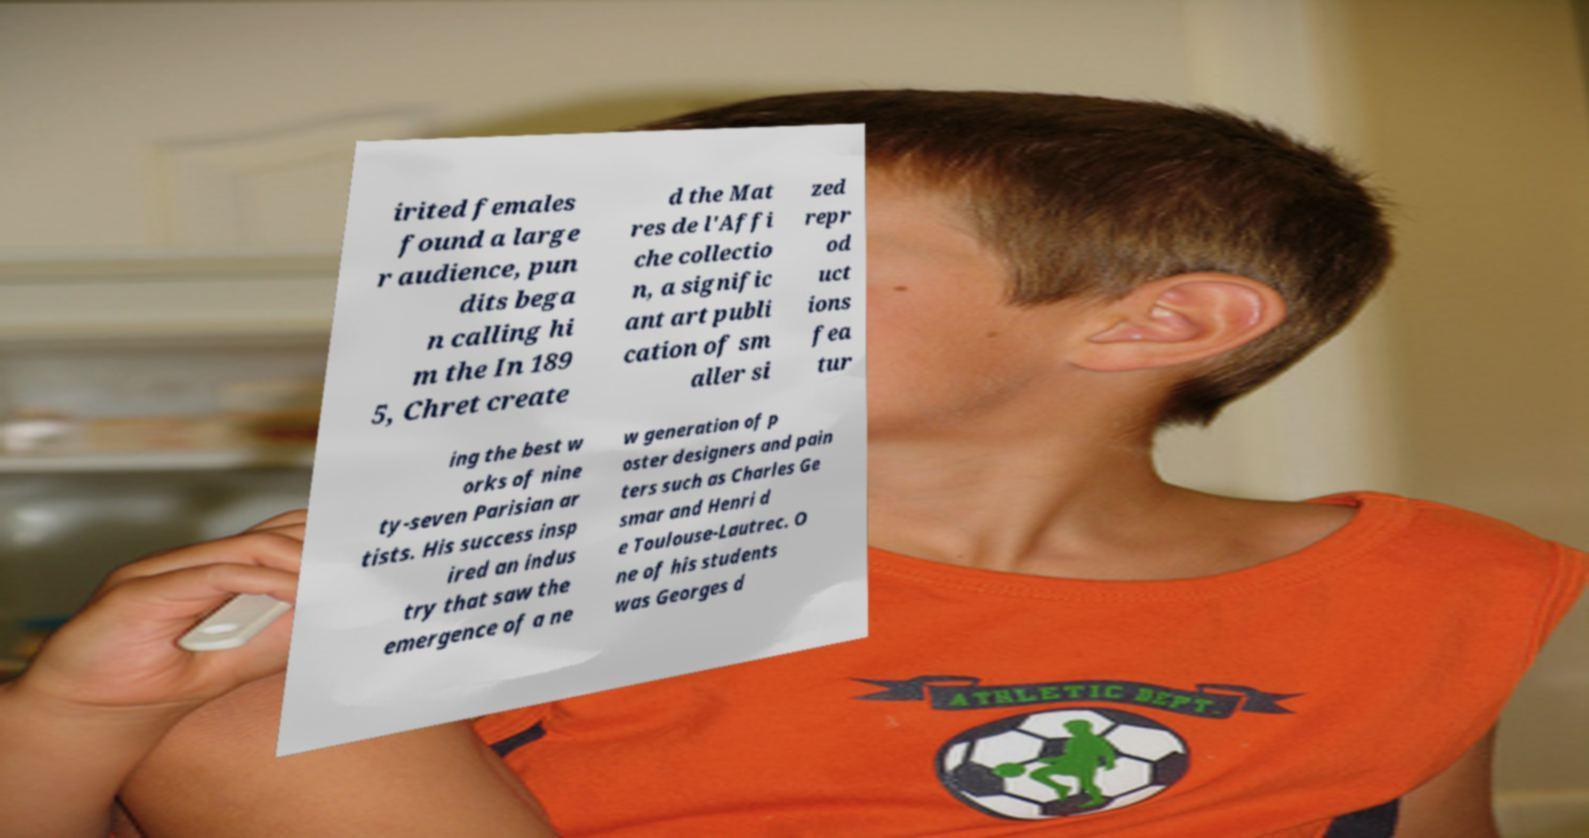Please read and relay the text visible in this image. What does it say? irited females found a large r audience, pun dits bega n calling hi m the In 189 5, Chret create d the Mat res de l'Affi che collectio n, a signific ant art publi cation of sm aller si zed repr od uct ions fea tur ing the best w orks of nine ty-seven Parisian ar tists. His success insp ired an indus try that saw the emergence of a ne w generation of p oster designers and pain ters such as Charles Ge smar and Henri d e Toulouse-Lautrec. O ne of his students was Georges d 